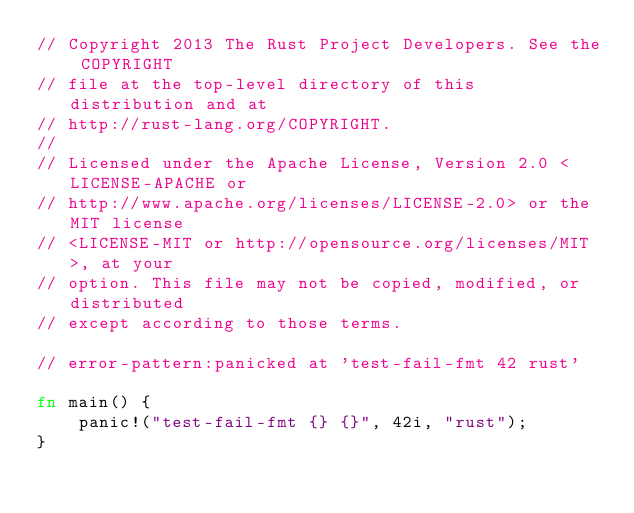<code> <loc_0><loc_0><loc_500><loc_500><_Rust_>// Copyright 2013 The Rust Project Developers. See the COPYRIGHT
// file at the top-level directory of this distribution and at
// http://rust-lang.org/COPYRIGHT.
//
// Licensed under the Apache License, Version 2.0 <LICENSE-APACHE or
// http://www.apache.org/licenses/LICENSE-2.0> or the MIT license
// <LICENSE-MIT or http://opensource.org/licenses/MIT>, at your
// option. This file may not be copied, modified, or distributed
// except according to those terms.

// error-pattern:panicked at 'test-fail-fmt 42 rust'

fn main() {
    panic!("test-fail-fmt {} {}", 42i, "rust");
}
</code> 